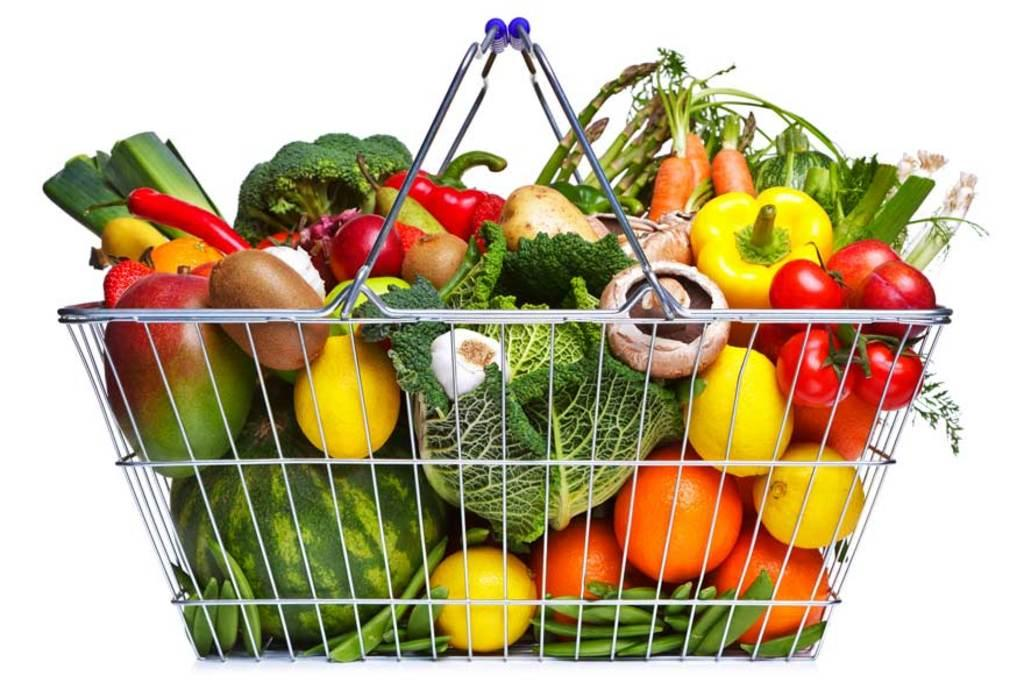What object is present in the image that can hold items? There is a basket in the image. What types of food can be found in the basket? The basket contains vegetables and fruits. What type of plastic material is covering the wound on the floor in the image? There is no plastic material or wound present in the image; it only features a basket containing vegetables and fruits. 